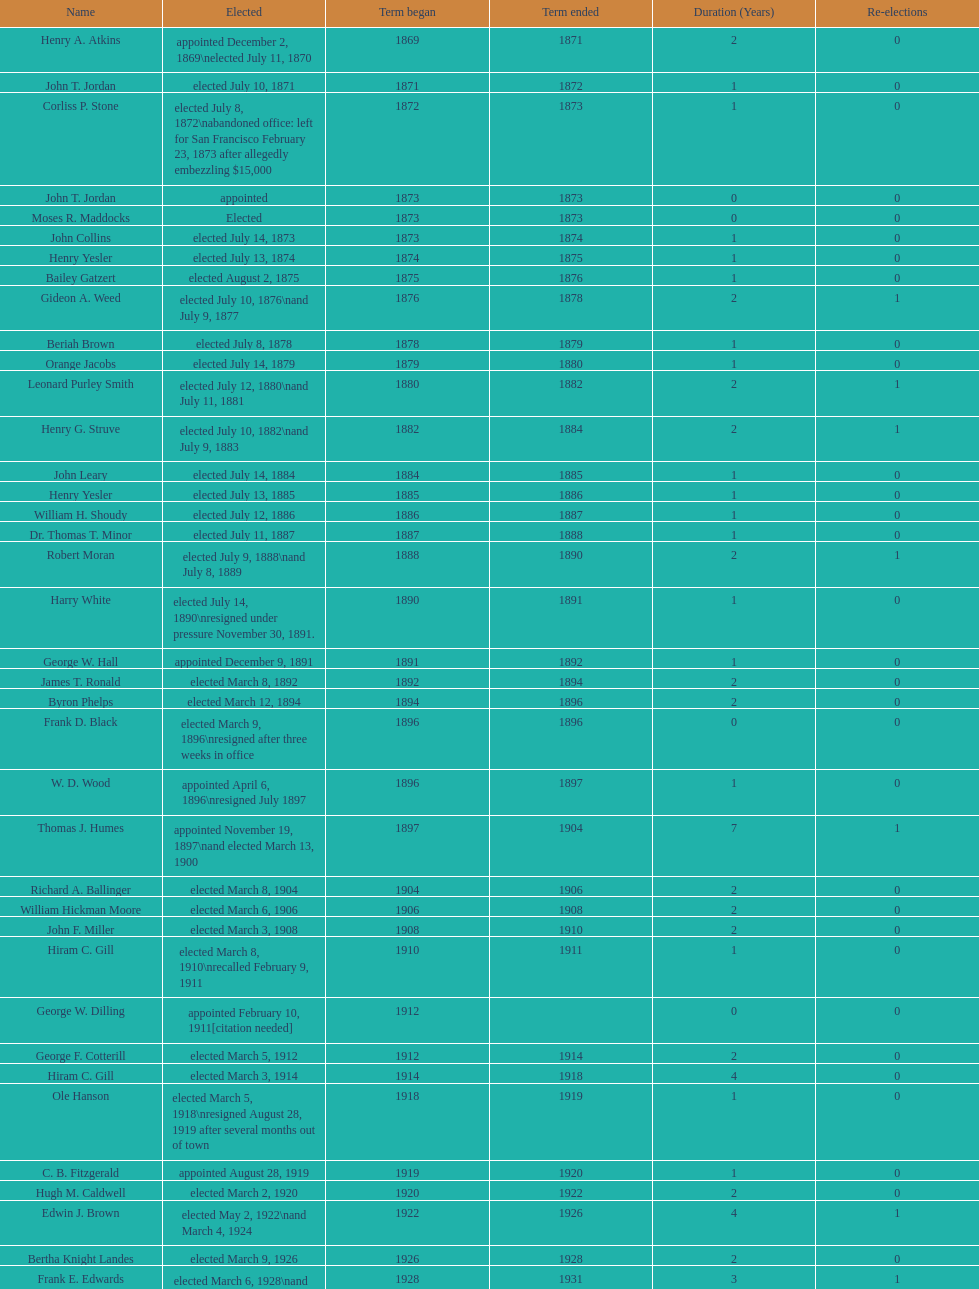Who was mayor of seattle, washington before being appointed to department of transportation during the nixon administration? James d'Orma Braman. 